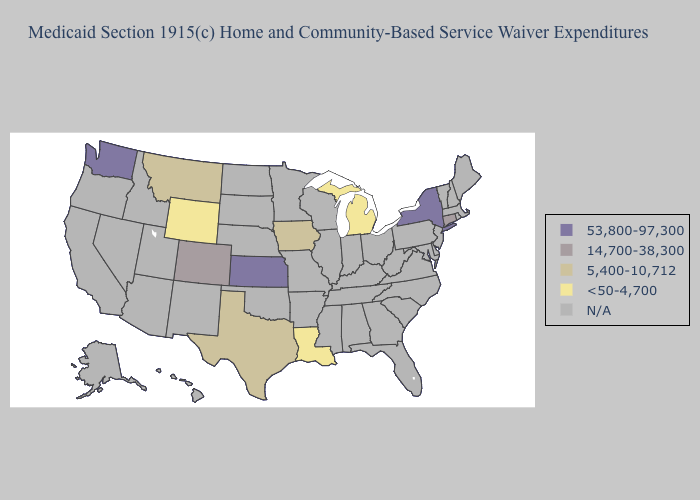What is the value of Missouri?
Quick response, please. N/A. Among the states that border Massachusetts , does New York have the highest value?
Be succinct. Yes. Does Iowa have the lowest value in the USA?
Write a very short answer. No. Among the states that border Idaho , does Montana have the highest value?
Answer briefly. No. Name the states that have a value in the range 53,800-97,300?
Concise answer only. Kansas, New York, Washington. What is the value of Mississippi?
Give a very brief answer. N/A. Name the states that have a value in the range 14,700-38,300?
Answer briefly. Colorado, Connecticut. What is the highest value in states that border Arkansas?
Concise answer only. 5,400-10,712. Which states have the lowest value in the West?
Write a very short answer. Wyoming. Does the first symbol in the legend represent the smallest category?
Write a very short answer. No. Name the states that have a value in the range 5,400-10,712?
Quick response, please. Iowa, Montana, Texas. What is the value of Massachusetts?
Short answer required. N/A. What is the lowest value in the USA?
Short answer required. <50-4,700. Among the states that border Louisiana , which have the lowest value?
Give a very brief answer. Texas. 